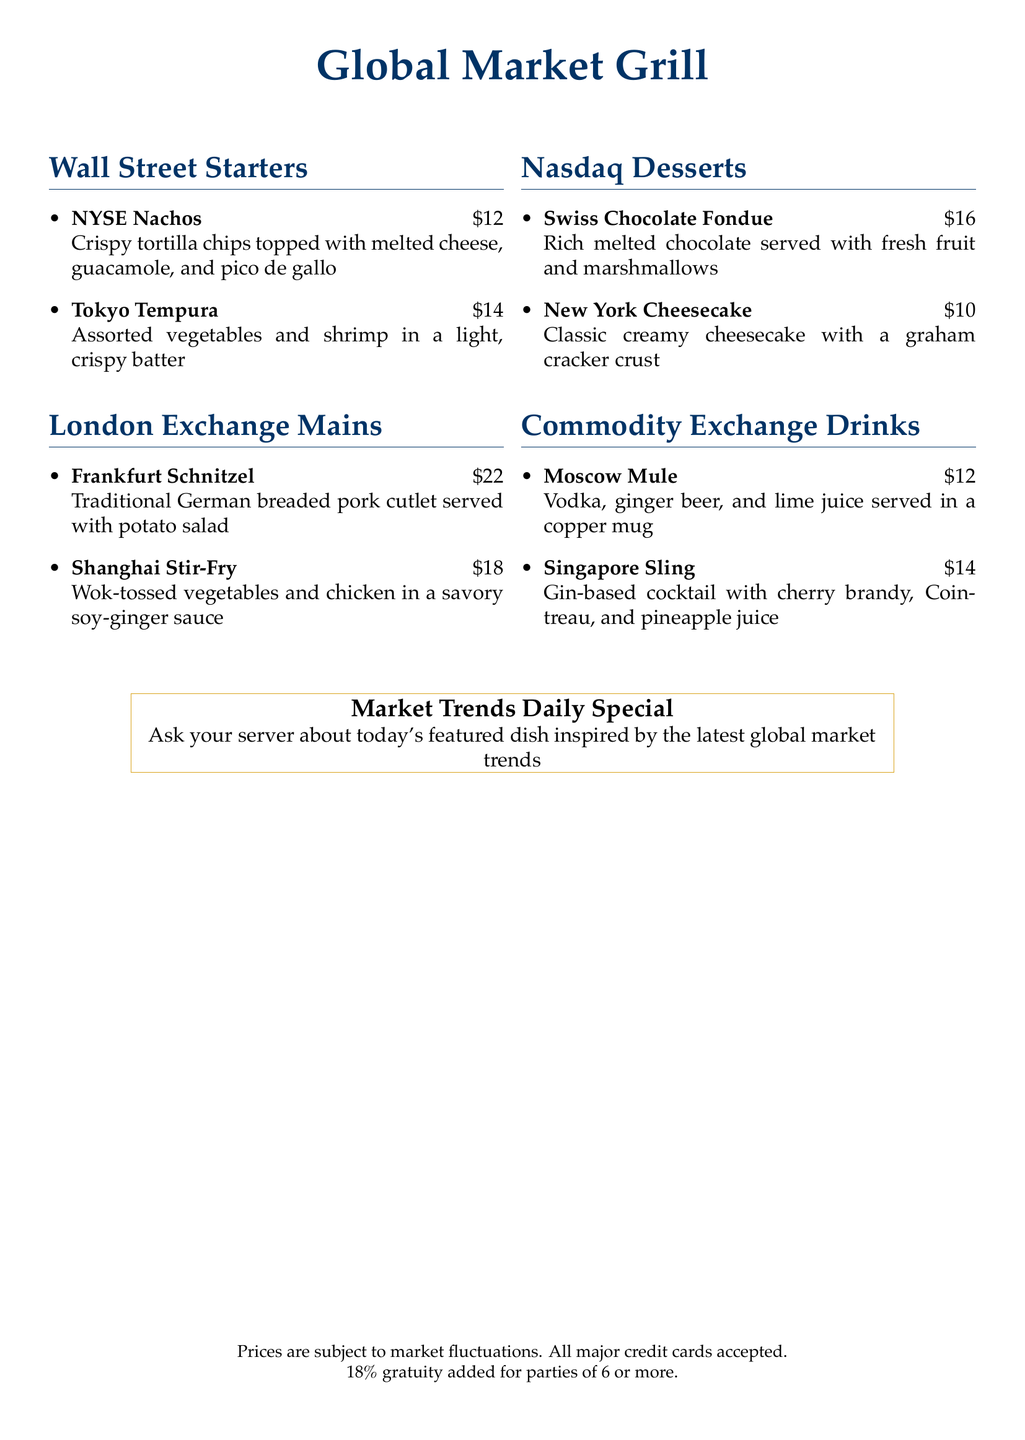What is the price of NYSE Nachos? The price of NYSE Nachos is specified in the menu as \$12.
Answer: \$12 What type of garnish comes with the Frankfurt Schnitzel? The menu specifies that Frankfurt Schnitzel is served with potato salad.
Answer: potato salad Which cocktail is served in a copper mug? The menu states that the Moscow Mule is served in a copper mug.
Answer: Moscow Mule What is the focus of the Market Trends Daily Special? The daily special is inspired by the latest global market trends, as indicated in the menu.
Answer: latest global market trends How many desserts are listed on the menu? The document lists two desserts under the Nasdaq Desserts section.
Answer: two What is the price of the New York Cheesecake? The menu states that the price for New York Cheesecake is \$10.
Answer: \$10 Which drink includes cherry brandy? The Singapore Sling is the drink that includes cherry brandy, according to the menu.
Answer: Singapore Sling Which city is mentioned in the dish Tokyo Tempura? The name Tokyo in "Tokyo Tempura" refers to the city and is clearly listed on the menu.
Answer: Tokyo 